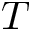<formula> <loc_0><loc_0><loc_500><loc_500>T</formula> 